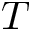<formula> <loc_0><loc_0><loc_500><loc_500>T</formula> 